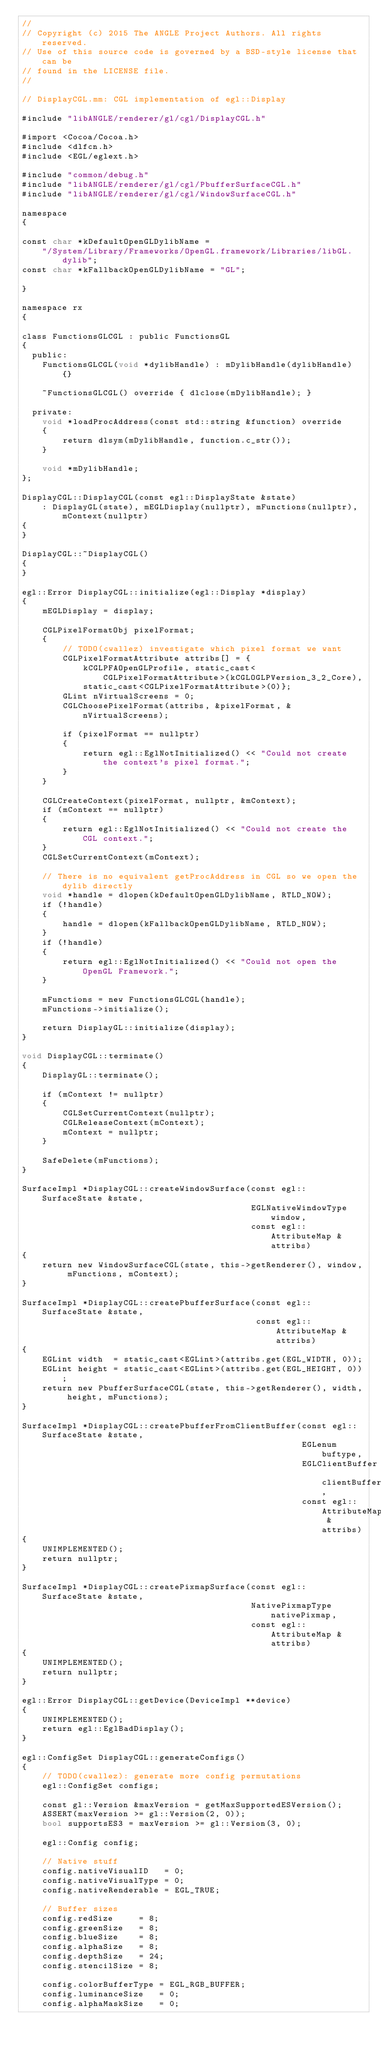Convert code to text. <code><loc_0><loc_0><loc_500><loc_500><_ObjectiveC_>//
// Copyright (c) 2015 The ANGLE Project Authors. All rights reserved.
// Use of this source code is governed by a BSD-style license that can be
// found in the LICENSE file.
//

// DisplayCGL.mm: CGL implementation of egl::Display

#include "libANGLE/renderer/gl/cgl/DisplayCGL.h"

#import <Cocoa/Cocoa.h>
#include <dlfcn.h>
#include <EGL/eglext.h>

#include "common/debug.h"
#include "libANGLE/renderer/gl/cgl/PbufferSurfaceCGL.h"
#include "libANGLE/renderer/gl/cgl/WindowSurfaceCGL.h"

namespace
{

const char *kDefaultOpenGLDylibName =
    "/System/Library/Frameworks/OpenGL.framework/Libraries/libGL.dylib";
const char *kFallbackOpenGLDylibName = "GL";

}

namespace rx
{

class FunctionsGLCGL : public FunctionsGL
{
  public:
    FunctionsGLCGL(void *dylibHandle) : mDylibHandle(dylibHandle) {}

    ~FunctionsGLCGL() override { dlclose(mDylibHandle); }

  private:
    void *loadProcAddress(const std::string &function) override
    {
        return dlsym(mDylibHandle, function.c_str());
    }

    void *mDylibHandle;
};

DisplayCGL::DisplayCGL(const egl::DisplayState &state)
    : DisplayGL(state), mEGLDisplay(nullptr), mFunctions(nullptr), mContext(nullptr)
{
}

DisplayCGL::~DisplayCGL()
{
}

egl::Error DisplayCGL::initialize(egl::Display *display)
{
    mEGLDisplay = display;

    CGLPixelFormatObj pixelFormat;
    {
        // TODO(cwallez) investigate which pixel format we want
        CGLPixelFormatAttribute attribs[] = {
            kCGLPFAOpenGLProfile, static_cast<CGLPixelFormatAttribute>(kCGLOGLPVersion_3_2_Core),
            static_cast<CGLPixelFormatAttribute>(0)};
        GLint nVirtualScreens = 0;
        CGLChoosePixelFormat(attribs, &pixelFormat, &nVirtualScreens);

        if (pixelFormat == nullptr)
        {
            return egl::EglNotInitialized() << "Could not create the context's pixel format.";
        }
    }

    CGLCreateContext(pixelFormat, nullptr, &mContext);
    if (mContext == nullptr)
    {
        return egl::EglNotInitialized() << "Could not create the CGL context.";
    }
    CGLSetCurrentContext(mContext);

    // There is no equivalent getProcAddress in CGL so we open the dylib directly
    void *handle = dlopen(kDefaultOpenGLDylibName, RTLD_NOW);
    if (!handle)
    {
        handle = dlopen(kFallbackOpenGLDylibName, RTLD_NOW);
    }
    if (!handle)
    {
        return egl::EglNotInitialized() << "Could not open the OpenGL Framework.";
    }

    mFunctions = new FunctionsGLCGL(handle);
    mFunctions->initialize();

    return DisplayGL::initialize(display);
}

void DisplayCGL::terminate()
{
    DisplayGL::terminate();

    if (mContext != nullptr)
    {
        CGLSetCurrentContext(nullptr);
        CGLReleaseContext(mContext);
        mContext = nullptr;
    }

    SafeDelete(mFunctions);
}

SurfaceImpl *DisplayCGL::createWindowSurface(const egl::SurfaceState &state,
                                             EGLNativeWindowType window,
                                             const egl::AttributeMap &attribs)
{
    return new WindowSurfaceCGL(state, this->getRenderer(), window, mFunctions, mContext);
}

SurfaceImpl *DisplayCGL::createPbufferSurface(const egl::SurfaceState &state,
                                              const egl::AttributeMap &attribs)
{
    EGLint width  = static_cast<EGLint>(attribs.get(EGL_WIDTH, 0));
    EGLint height = static_cast<EGLint>(attribs.get(EGL_HEIGHT, 0));
    return new PbufferSurfaceCGL(state, this->getRenderer(), width, height, mFunctions);
}

SurfaceImpl *DisplayCGL::createPbufferFromClientBuffer(const egl::SurfaceState &state,
                                                       EGLenum buftype,
                                                       EGLClientBuffer clientBuffer,
                                                       const egl::AttributeMap &attribs)
{
    UNIMPLEMENTED();
    return nullptr;
}

SurfaceImpl *DisplayCGL::createPixmapSurface(const egl::SurfaceState &state,
                                             NativePixmapType nativePixmap,
                                             const egl::AttributeMap &attribs)
{
    UNIMPLEMENTED();
    return nullptr;
}

egl::Error DisplayCGL::getDevice(DeviceImpl **device)
{
    UNIMPLEMENTED();
    return egl::EglBadDisplay();
}

egl::ConfigSet DisplayCGL::generateConfigs()
{
    // TODO(cwallez): generate more config permutations
    egl::ConfigSet configs;

    const gl::Version &maxVersion = getMaxSupportedESVersion();
    ASSERT(maxVersion >= gl::Version(2, 0));
    bool supportsES3 = maxVersion >= gl::Version(3, 0);

    egl::Config config;

    // Native stuff
    config.nativeVisualID   = 0;
    config.nativeVisualType = 0;
    config.nativeRenderable = EGL_TRUE;

    // Buffer sizes
    config.redSize     = 8;
    config.greenSize   = 8;
    config.blueSize    = 8;
    config.alphaSize   = 8;
    config.depthSize   = 24;
    config.stencilSize = 8;

    config.colorBufferType = EGL_RGB_BUFFER;
    config.luminanceSize   = 0;
    config.alphaMaskSize   = 0;
</code> 